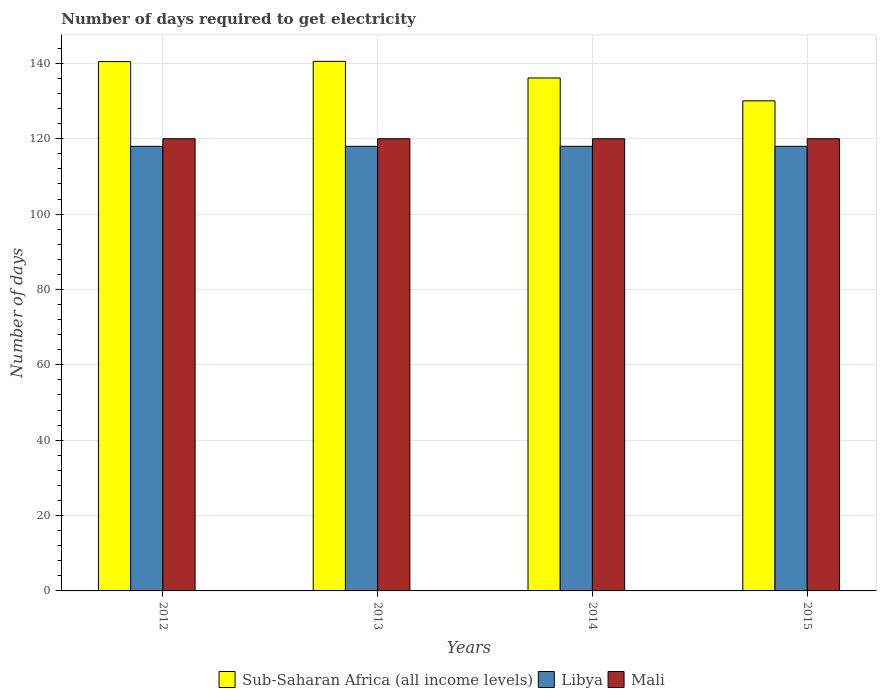How many different coloured bars are there?
Offer a terse response. 3. How many groups of bars are there?
Provide a succinct answer. 4. Are the number of bars per tick equal to the number of legend labels?
Provide a succinct answer. Yes. What is the label of the 1st group of bars from the left?
Give a very brief answer. 2012. In how many cases, is the number of bars for a given year not equal to the number of legend labels?
Your answer should be compact. 0. What is the number of days required to get electricity in in Libya in 2013?
Offer a terse response. 118. Across all years, what is the maximum number of days required to get electricity in in Libya?
Make the answer very short. 118. Across all years, what is the minimum number of days required to get electricity in in Mali?
Offer a terse response. 120. In which year was the number of days required to get electricity in in Libya maximum?
Your answer should be compact. 2012. In which year was the number of days required to get electricity in in Sub-Saharan Africa (all income levels) minimum?
Make the answer very short. 2015. What is the total number of days required to get electricity in in Mali in the graph?
Provide a short and direct response. 480. What is the difference between the number of days required to get electricity in in Sub-Saharan Africa (all income levels) in 2012 and that in 2013?
Offer a very short reply. -0.07. What is the difference between the number of days required to get electricity in in Sub-Saharan Africa (all income levels) in 2015 and the number of days required to get electricity in in Mali in 2013?
Provide a succinct answer. 10.07. What is the average number of days required to get electricity in in Mali per year?
Offer a terse response. 120. In the year 2013, what is the difference between the number of days required to get electricity in in Libya and number of days required to get electricity in in Sub-Saharan Africa (all income levels)?
Your answer should be compact. -22.54. In how many years, is the number of days required to get electricity in in Mali greater than 124 days?
Ensure brevity in your answer.  0. What is the ratio of the number of days required to get electricity in in Sub-Saharan Africa (all income levels) in 2014 to that in 2015?
Your response must be concise. 1.05. Is the number of days required to get electricity in in Sub-Saharan Africa (all income levels) in 2014 less than that in 2015?
Your answer should be very brief. No. Is the difference between the number of days required to get electricity in in Libya in 2012 and 2015 greater than the difference between the number of days required to get electricity in in Sub-Saharan Africa (all income levels) in 2012 and 2015?
Provide a succinct answer. No. What is the difference between the highest and the second highest number of days required to get electricity in in Mali?
Provide a short and direct response. 0. Is the sum of the number of days required to get electricity in in Libya in 2012 and 2014 greater than the maximum number of days required to get electricity in in Sub-Saharan Africa (all income levels) across all years?
Ensure brevity in your answer.  Yes. What does the 1st bar from the left in 2013 represents?
Provide a short and direct response. Sub-Saharan Africa (all income levels). What does the 3rd bar from the right in 2015 represents?
Offer a very short reply. Sub-Saharan Africa (all income levels). Is it the case that in every year, the sum of the number of days required to get electricity in in Sub-Saharan Africa (all income levels) and number of days required to get electricity in in Libya is greater than the number of days required to get electricity in in Mali?
Your answer should be very brief. Yes. How many years are there in the graph?
Your answer should be very brief. 4. Does the graph contain any zero values?
Make the answer very short. No. Where does the legend appear in the graph?
Offer a terse response. Bottom center. What is the title of the graph?
Offer a terse response. Number of days required to get electricity. Does "Greenland" appear as one of the legend labels in the graph?
Your response must be concise. No. What is the label or title of the Y-axis?
Ensure brevity in your answer.  Number of days. What is the Number of days of Sub-Saharan Africa (all income levels) in 2012?
Your response must be concise. 140.48. What is the Number of days in Libya in 2012?
Give a very brief answer. 118. What is the Number of days of Mali in 2012?
Ensure brevity in your answer.  120. What is the Number of days of Sub-Saharan Africa (all income levels) in 2013?
Offer a terse response. 140.54. What is the Number of days of Libya in 2013?
Offer a terse response. 118. What is the Number of days of Mali in 2013?
Your answer should be compact. 120. What is the Number of days in Sub-Saharan Africa (all income levels) in 2014?
Your answer should be compact. 136.13. What is the Number of days of Libya in 2014?
Keep it short and to the point. 118. What is the Number of days in Mali in 2014?
Provide a succinct answer. 120. What is the Number of days of Sub-Saharan Africa (all income levels) in 2015?
Offer a very short reply. 130.07. What is the Number of days of Libya in 2015?
Your answer should be compact. 118. What is the Number of days in Mali in 2015?
Your answer should be compact. 120. Across all years, what is the maximum Number of days of Sub-Saharan Africa (all income levels)?
Offer a very short reply. 140.54. Across all years, what is the maximum Number of days of Libya?
Provide a short and direct response. 118. Across all years, what is the maximum Number of days of Mali?
Give a very brief answer. 120. Across all years, what is the minimum Number of days of Sub-Saharan Africa (all income levels)?
Provide a short and direct response. 130.07. Across all years, what is the minimum Number of days in Libya?
Keep it short and to the point. 118. Across all years, what is the minimum Number of days of Mali?
Offer a very short reply. 120. What is the total Number of days of Sub-Saharan Africa (all income levels) in the graph?
Your answer should be compact. 547.22. What is the total Number of days in Libya in the graph?
Keep it short and to the point. 472. What is the total Number of days of Mali in the graph?
Provide a succinct answer. 480. What is the difference between the Number of days in Sub-Saharan Africa (all income levels) in 2012 and that in 2013?
Your answer should be very brief. -0.07. What is the difference between the Number of days in Libya in 2012 and that in 2013?
Keep it short and to the point. 0. What is the difference between the Number of days of Sub-Saharan Africa (all income levels) in 2012 and that in 2014?
Give a very brief answer. 4.35. What is the difference between the Number of days in Libya in 2012 and that in 2014?
Your answer should be compact. 0. What is the difference between the Number of days in Mali in 2012 and that in 2014?
Provide a short and direct response. 0. What is the difference between the Number of days of Sub-Saharan Africa (all income levels) in 2012 and that in 2015?
Your answer should be compact. 10.41. What is the difference between the Number of days in Libya in 2012 and that in 2015?
Your response must be concise. 0. What is the difference between the Number of days of Sub-Saharan Africa (all income levels) in 2013 and that in 2014?
Offer a very short reply. 4.41. What is the difference between the Number of days in Libya in 2013 and that in 2014?
Make the answer very short. 0. What is the difference between the Number of days of Sub-Saharan Africa (all income levels) in 2013 and that in 2015?
Provide a short and direct response. 10.48. What is the difference between the Number of days of Sub-Saharan Africa (all income levels) in 2014 and that in 2015?
Make the answer very short. 6.06. What is the difference between the Number of days in Sub-Saharan Africa (all income levels) in 2012 and the Number of days in Libya in 2013?
Provide a short and direct response. 22.48. What is the difference between the Number of days in Sub-Saharan Africa (all income levels) in 2012 and the Number of days in Mali in 2013?
Offer a very short reply. 20.48. What is the difference between the Number of days of Libya in 2012 and the Number of days of Mali in 2013?
Offer a very short reply. -2. What is the difference between the Number of days in Sub-Saharan Africa (all income levels) in 2012 and the Number of days in Libya in 2014?
Offer a terse response. 22.48. What is the difference between the Number of days of Sub-Saharan Africa (all income levels) in 2012 and the Number of days of Mali in 2014?
Give a very brief answer. 20.48. What is the difference between the Number of days in Libya in 2012 and the Number of days in Mali in 2014?
Offer a terse response. -2. What is the difference between the Number of days in Sub-Saharan Africa (all income levels) in 2012 and the Number of days in Libya in 2015?
Ensure brevity in your answer.  22.48. What is the difference between the Number of days of Sub-Saharan Africa (all income levels) in 2012 and the Number of days of Mali in 2015?
Keep it short and to the point. 20.48. What is the difference between the Number of days in Libya in 2012 and the Number of days in Mali in 2015?
Give a very brief answer. -2. What is the difference between the Number of days in Sub-Saharan Africa (all income levels) in 2013 and the Number of days in Libya in 2014?
Your answer should be compact. 22.54. What is the difference between the Number of days of Sub-Saharan Africa (all income levels) in 2013 and the Number of days of Mali in 2014?
Give a very brief answer. 20.54. What is the difference between the Number of days of Sub-Saharan Africa (all income levels) in 2013 and the Number of days of Libya in 2015?
Provide a succinct answer. 22.54. What is the difference between the Number of days of Sub-Saharan Africa (all income levels) in 2013 and the Number of days of Mali in 2015?
Offer a very short reply. 20.54. What is the difference between the Number of days in Libya in 2013 and the Number of days in Mali in 2015?
Offer a very short reply. -2. What is the difference between the Number of days of Sub-Saharan Africa (all income levels) in 2014 and the Number of days of Libya in 2015?
Your answer should be compact. 18.13. What is the difference between the Number of days of Sub-Saharan Africa (all income levels) in 2014 and the Number of days of Mali in 2015?
Your answer should be compact. 16.13. What is the average Number of days in Sub-Saharan Africa (all income levels) per year?
Offer a terse response. 136.81. What is the average Number of days in Libya per year?
Make the answer very short. 118. What is the average Number of days in Mali per year?
Keep it short and to the point. 120. In the year 2012, what is the difference between the Number of days in Sub-Saharan Africa (all income levels) and Number of days in Libya?
Your response must be concise. 22.48. In the year 2012, what is the difference between the Number of days of Sub-Saharan Africa (all income levels) and Number of days of Mali?
Give a very brief answer. 20.48. In the year 2013, what is the difference between the Number of days in Sub-Saharan Africa (all income levels) and Number of days in Libya?
Offer a very short reply. 22.54. In the year 2013, what is the difference between the Number of days in Sub-Saharan Africa (all income levels) and Number of days in Mali?
Your response must be concise. 20.54. In the year 2013, what is the difference between the Number of days in Libya and Number of days in Mali?
Provide a short and direct response. -2. In the year 2014, what is the difference between the Number of days in Sub-Saharan Africa (all income levels) and Number of days in Libya?
Provide a succinct answer. 18.13. In the year 2014, what is the difference between the Number of days of Sub-Saharan Africa (all income levels) and Number of days of Mali?
Your response must be concise. 16.13. In the year 2014, what is the difference between the Number of days in Libya and Number of days in Mali?
Provide a short and direct response. -2. In the year 2015, what is the difference between the Number of days in Sub-Saharan Africa (all income levels) and Number of days in Libya?
Keep it short and to the point. 12.07. In the year 2015, what is the difference between the Number of days in Sub-Saharan Africa (all income levels) and Number of days in Mali?
Offer a very short reply. 10.07. What is the ratio of the Number of days of Sub-Saharan Africa (all income levels) in 2012 to that in 2014?
Keep it short and to the point. 1.03. What is the ratio of the Number of days in Sub-Saharan Africa (all income levels) in 2012 to that in 2015?
Offer a very short reply. 1.08. What is the ratio of the Number of days of Mali in 2012 to that in 2015?
Ensure brevity in your answer.  1. What is the ratio of the Number of days in Sub-Saharan Africa (all income levels) in 2013 to that in 2014?
Your response must be concise. 1.03. What is the ratio of the Number of days of Sub-Saharan Africa (all income levels) in 2013 to that in 2015?
Offer a very short reply. 1.08. What is the ratio of the Number of days of Sub-Saharan Africa (all income levels) in 2014 to that in 2015?
Keep it short and to the point. 1.05. What is the ratio of the Number of days in Libya in 2014 to that in 2015?
Your answer should be very brief. 1. What is the ratio of the Number of days of Mali in 2014 to that in 2015?
Give a very brief answer. 1. What is the difference between the highest and the second highest Number of days of Sub-Saharan Africa (all income levels)?
Your answer should be very brief. 0.07. What is the difference between the highest and the lowest Number of days in Sub-Saharan Africa (all income levels)?
Provide a succinct answer. 10.48. What is the difference between the highest and the lowest Number of days of Libya?
Provide a short and direct response. 0. 